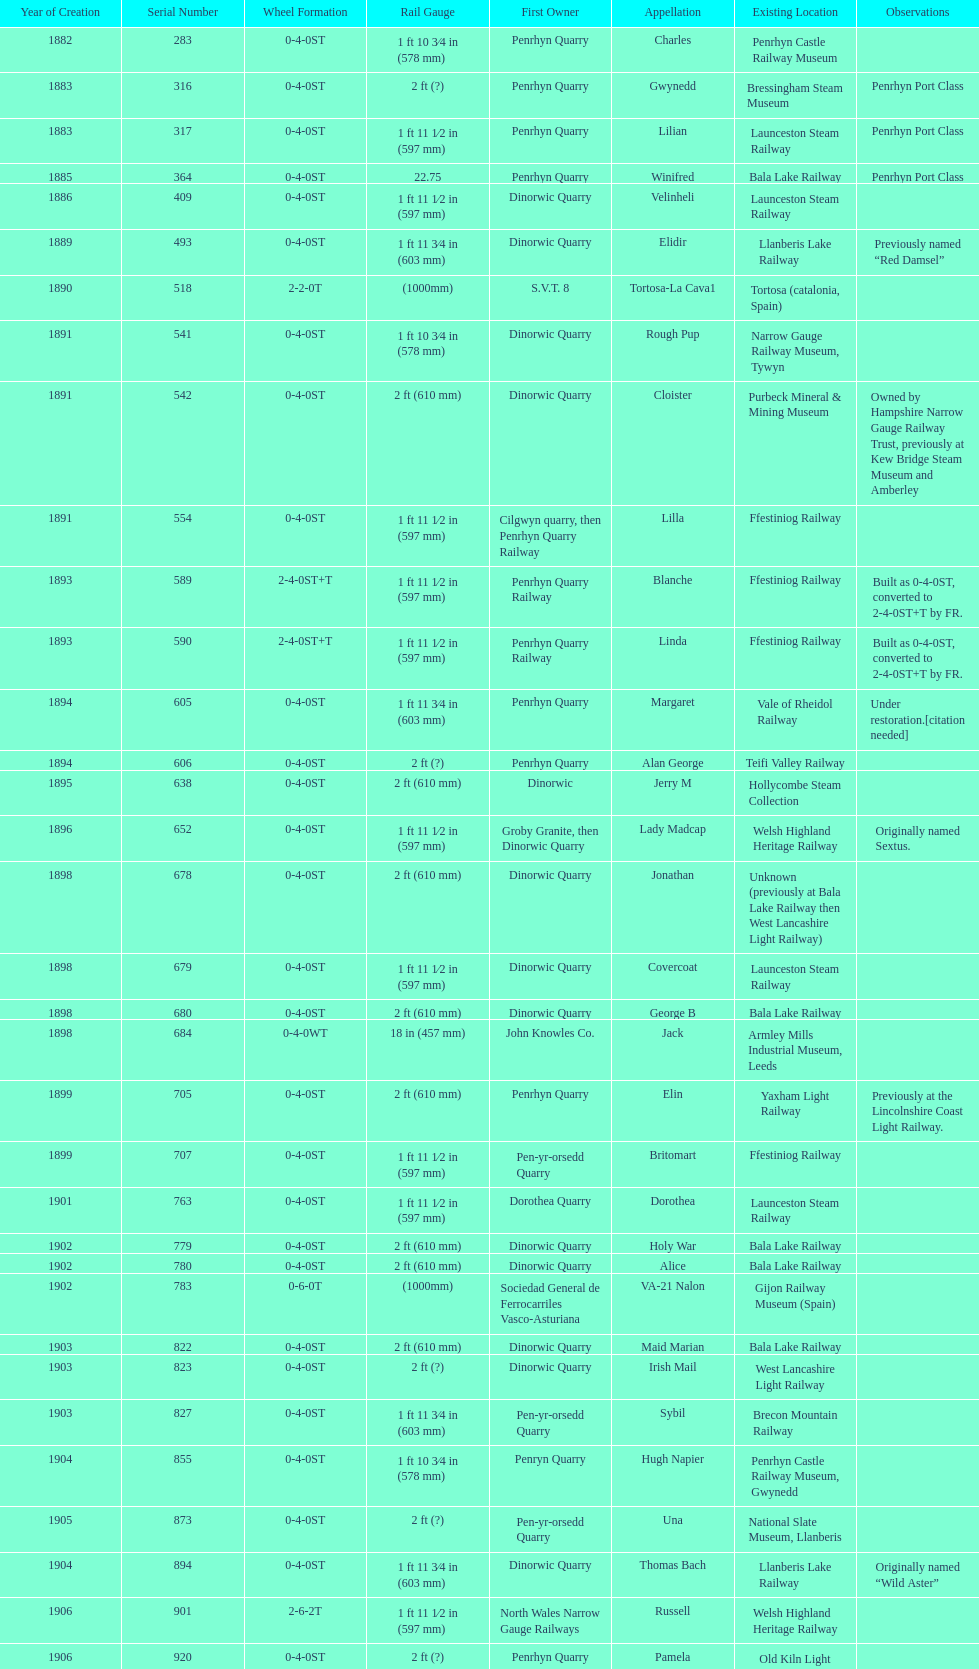What is the name of the last locomotive to be located at the bressingham steam museum? Gwynedd. 